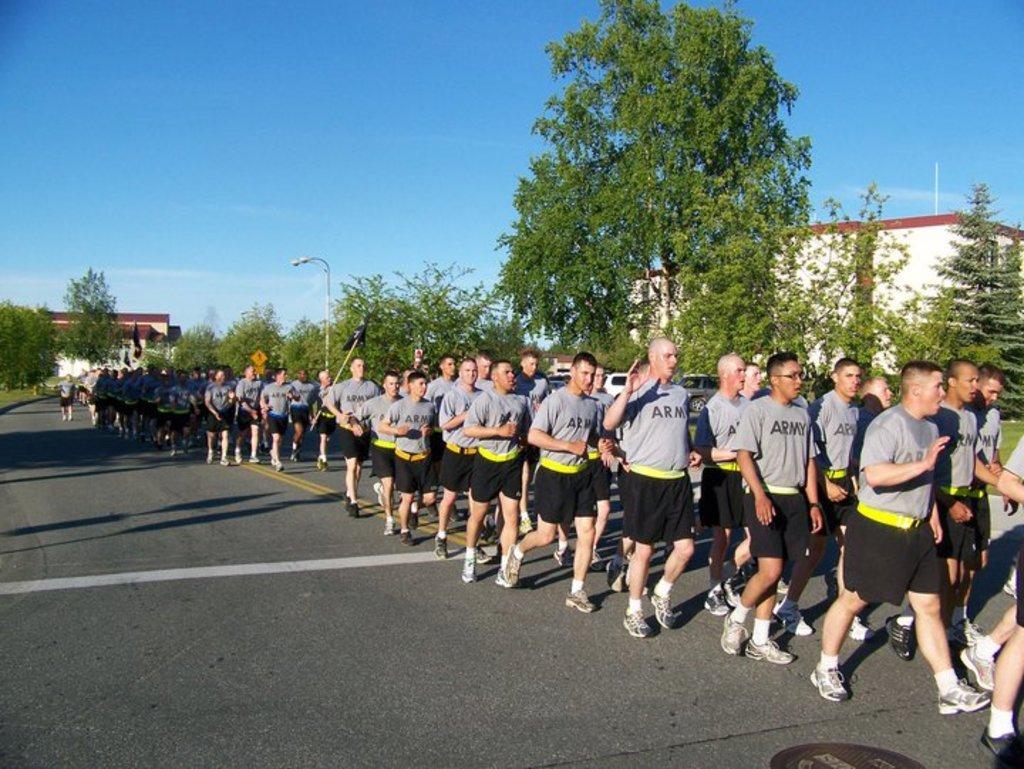Could you give a brief overview of what you see in this image? In this image, on the right side, we can see a group of people walking on the road. On the right side, we can see some trees, plants, street light, building. In the background, we can see some trees, plants, building. At the top, we can see a sky which is in blue color, at the bottom, we can see a road and a grass. 